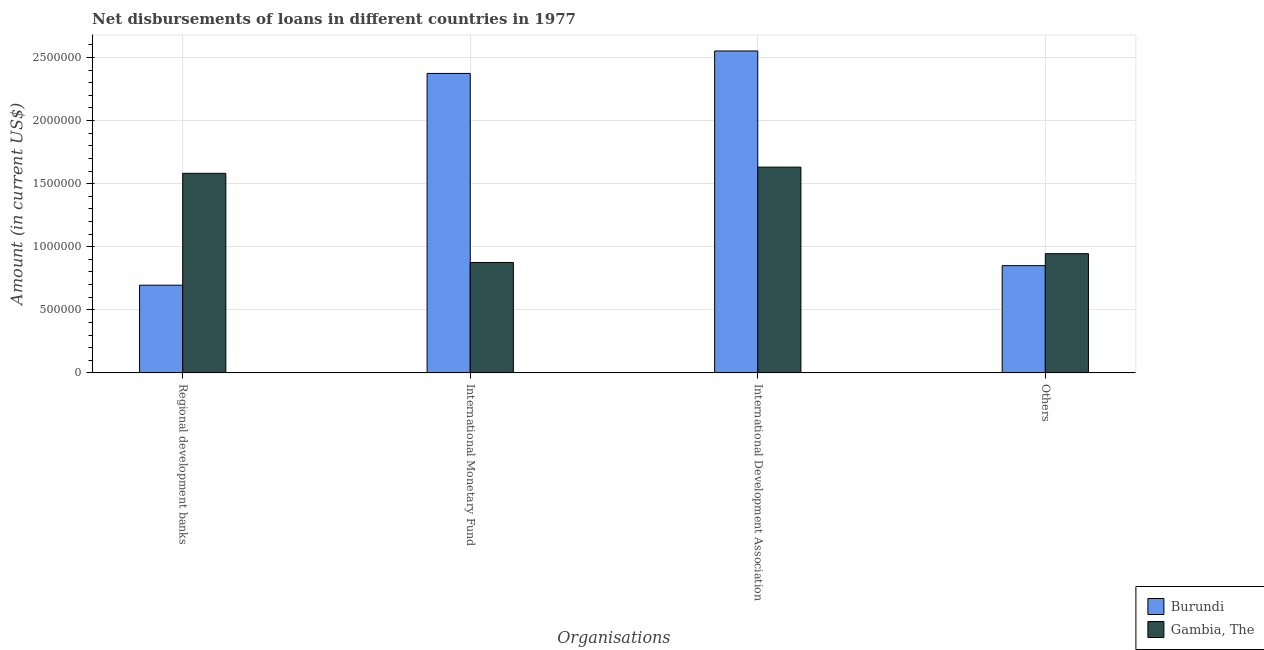How many groups of bars are there?
Make the answer very short. 4. Are the number of bars per tick equal to the number of legend labels?
Your response must be concise. Yes. What is the label of the 1st group of bars from the left?
Your answer should be very brief. Regional development banks. What is the amount of loan disimbursed by international development association in Gambia, The?
Provide a short and direct response. 1.63e+06. Across all countries, what is the maximum amount of loan disimbursed by international development association?
Your answer should be very brief. 2.55e+06. Across all countries, what is the minimum amount of loan disimbursed by international development association?
Keep it short and to the point. 1.63e+06. In which country was the amount of loan disimbursed by international development association maximum?
Keep it short and to the point. Burundi. In which country was the amount of loan disimbursed by international monetary fund minimum?
Make the answer very short. Gambia, The. What is the total amount of loan disimbursed by international monetary fund in the graph?
Give a very brief answer. 3.25e+06. What is the difference between the amount of loan disimbursed by international monetary fund in Gambia, The and that in Burundi?
Offer a terse response. -1.50e+06. What is the difference between the amount of loan disimbursed by international monetary fund in Gambia, The and the amount of loan disimbursed by regional development banks in Burundi?
Keep it short and to the point. 1.80e+05. What is the average amount of loan disimbursed by regional development banks per country?
Make the answer very short. 1.14e+06. What is the difference between the amount of loan disimbursed by regional development banks and amount of loan disimbursed by international monetary fund in Gambia, The?
Ensure brevity in your answer.  7.07e+05. In how many countries, is the amount of loan disimbursed by international monetary fund greater than 1800000 US$?
Ensure brevity in your answer.  1. What is the ratio of the amount of loan disimbursed by international development association in Burundi to that in Gambia, The?
Ensure brevity in your answer.  1.56. Is the difference between the amount of loan disimbursed by other organisations in Gambia, The and Burundi greater than the difference between the amount of loan disimbursed by international development association in Gambia, The and Burundi?
Your answer should be very brief. Yes. What is the difference between the highest and the second highest amount of loan disimbursed by international development association?
Keep it short and to the point. 9.21e+05. What is the difference between the highest and the lowest amount of loan disimbursed by other organisations?
Give a very brief answer. 9.50e+04. Is the sum of the amount of loan disimbursed by other organisations in Burundi and Gambia, The greater than the maximum amount of loan disimbursed by international monetary fund across all countries?
Your answer should be compact. No. Is it the case that in every country, the sum of the amount of loan disimbursed by regional development banks and amount of loan disimbursed by international development association is greater than the sum of amount of loan disimbursed by international monetary fund and amount of loan disimbursed by other organisations?
Ensure brevity in your answer.  No. What does the 1st bar from the left in International Development Association represents?
Give a very brief answer. Burundi. What does the 1st bar from the right in Others represents?
Give a very brief answer. Gambia, The. How many bars are there?
Ensure brevity in your answer.  8. Does the graph contain any zero values?
Provide a succinct answer. No. Does the graph contain grids?
Provide a succinct answer. Yes. How are the legend labels stacked?
Your answer should be compact. Vertical. What is the title of the graph?
Keep it short and to the point. Net disbursements of loans in different countries in 1977. What is the label or title of the X-axis?
Offer a terse response. Organisations. What is the Amount (in current US$) of Burundi in Regional development banks?
Provide a short and direct response. 6.95e+05. What is the Amount (in current US$) of Gambia, The in Regional development banks?
Offer a very short reply. 1.58e+06. What is the Amount (in current US$) in Burundi in International Monetary Fund?
Offer a very short reply. 2.37e+06. What is the Amount (in current US$) of Gambia, The in International Monetary Fund?
Give a very brief answer. 8.75e+05. What is the Amount (in current US$) of Burundi in International Development Association?
Keep it short and to the point. 2.55e+06. What is the Amount (in current US$) in Gambia, The in International Development Association?
Offer a very short reply. 1.63e+06. What is the Amount (in current US$) in Burundi in Others?
Your answer should be compact. 8.50e+05. What is the Amount (in current US$) of Gambia, The in Others?
Ensure brevity in your answer.  9.45e+05. Across all Organisations, what is the maximum Amount (in current US$) in Burundi?
Offer a very short reply. 2.55e+06. Across all Organisations, what is the maximum Amount (in current US$) of Gambia, The?
Your answer should be compact. 1.63e+06. Across all Organisations, what is the minimum Amount (in current US$) of Burundi?
Ensure brevity in your answer.  6.95e+05. Across all Organisations, what is the minimum Amount (in current US$) of Gambia, The?
Ensure brevity in your answer.  8.75e+05. What is the total Amount (in current US$) of Burundi in the graph?
Your answer should be compact. 6.47e+06. What is the total Amount (in current US$) in Gambia, The in the graph?
Make the answer very short. 5.03e+06. What is the difference between the Amount (in current US$) in Burundi in Regional development banks and that in International Monetary Fund?
Give a very brief answer. -1.68e+06. What is the difference between the Amount (in current US$) in Gambia, The in Regional development banks and that in International Monetary Fund?
Give a very brief answer. 7.07e+05. What is the difference between the Amount (in current US$) of Burundi in Regional development banks and that in International Development Association?
Keep it short and to the point. -1.86e+06. What is the difference between the Amount (in current US$) in Gambia, The in Regional development banks and that in International Development Association?
Make the answer very short. -4.90e+04. What is the difference between the Amount (in current US$) in Burundi in Regional development banks and that in Others?
Your response must be concise. -1.55e+05. What is the difference between the Amount (in current US$) of Gambia, The in Regional development banks and that in Others?
Provide a succinct answer. 6.37e+05. What is the difference between the Amount (in current US$) of Burundi in International Monetary Fund and that in International Development Association?
Offer a very short reply. -1.78e+05. What is the difference between the Amount (in current US$) of Gambia, The in International Monetary Fund and that in International Development Association?
Offer a terse response. -7.56e+05. What is the difference between the Amount (in current US$) of Burundi in International Monetary Fund and that in Others?
Keep it short and to the point. 1.52e+06. What is the difference between the Amount (in current US$) in Burundi in International Development Association and that in Others?
Keep it short and to the point. 1.70e+06. What is the difference between the Amount (in current US$) of Gambia, The in International Development Association and that in Others?
Ensure brevity in your answer.  6.86e+05. What is the difference between the Amount (in current US$) in Burundi in Regional development banks and the Amount (in current US$) in Gambia, The in International Development Association?
Keep it short and to the point. -9.36e+05. What is the difference between the Amount (in current US$) in Burundi in International Monetary Fund and the Amount (in current US$) in Gambia, The in International Development Association?
Make the answer very short. 7.43e+05. What is the difference between the Amount (in current US$) of Burundi in International Monetary Fund and the Amount (in current US$) of Gambia, The in Others?
Make the answer very short. 1.43e+06. What is the difference between the Amount (in current US$) of Burundi in International Development Association and the Amount (in current US$) of Gambia, The in Others?
Offer a very short reply. 1.61e+06. What is the average Amount (in current US$) in Burundi per Organisations?
Provide a short and direct response. 1.62e+06. What is the average Amount (in current US$) in Gambia, The per Organisations?
Your response must be concise. 1.26e+06. What is the difference between the Amount (in current US$) in Burundi and Amount (in current US$) in Gambia, The in Regional development banks?
Make the answer very short. -8.87e+05. What is the difference between the Amount (in current US$) in Burundi and Amount (in current US$) in Gambia, The in International Monetary Fund?
Make the answer very short. 1.50e+06. What is the difference between the Amount (in current US$) in Burundi and Amount (in current US$) in Gambia, The in International Development Association?
Offer a very short reply. 9.21e+05. What is the difference between the Amount (in current US$) of Burundi and Amount (in current US$) of Gambia, The in Others?
Give a very brief answer. -9.50e+04. What is the ratio of the Amount (in current US$) in Burundi in Regional development banks to that in International Monetary Fund?
Your answer should be compact. 0.29. What is the ratio of the Amount (in current US$) of Gambia, The in Regional development banks to that in International Monetary Fund?
Keep it short and to the point. 1.81. What is the ratio of the Amount (in current US$) of Burundi in Regional development banks to that in International Development Association?
Give a very brief answer. 0.27. What is the ratio of the Amount (in current US$) in Gambia, The in Regional development banks to that in International Development Association?
Provide a succinct answer. 0.97. What is the ratio of the Amount (in current US$) of Burundi in Regional development banks to that in Others?
Offer a terse response. 0.82. What is the ratio of the Amount (in current US$) of Gambia, The in Regional development banks to that in Others?
Provide a short and direct response. 1.67. What is the ratio of the Amount (in current US$) in Burundi in International Monetary Fund to that in International Development Association?
Offer a very short reply. 0.93. What is the ratio of the Amount (in current US$) in Gambia, The in International Monetary Fund to that in International Development Association?
Provide a short and direct response. 0.54. What is the ratio of the Amount (in current US$) of Burundi in International Monetary Fund to that in Others?
Your response must be concise. 2.79. What is the ratio of the Amount (in current US$) in Gambia, The in International Monetary Fund to that in Others?
Provide a succinct answer. 0.93. What is the ratio of the Amount (in current US$) of Burundi in International Development Association to that in Others?
Ensure brevity in your answer.  3. What is the ratio of the Amount (in current US$) of Gambia, The in International Development Association to that in Others?
Offer a terse response. 1.73. What is the difference between the highest and the second highest Amount (in current US$) of Burundi?
Offer a terse response. 1.78e+05. What is the difference between the highest and the second highest Amount (in current US$) of Gambia, The?
Keep it short and to the point. 4.90e+04. What is the difference between the highest and the lowest Amount (in current US$) in Burundi?
Provide a succinct answer. 1.86e+06. What is the difference between the highest and the lowest Amount (in current US$) of Gambia, The?
Your answer should be very brief. 7.56e+05. 